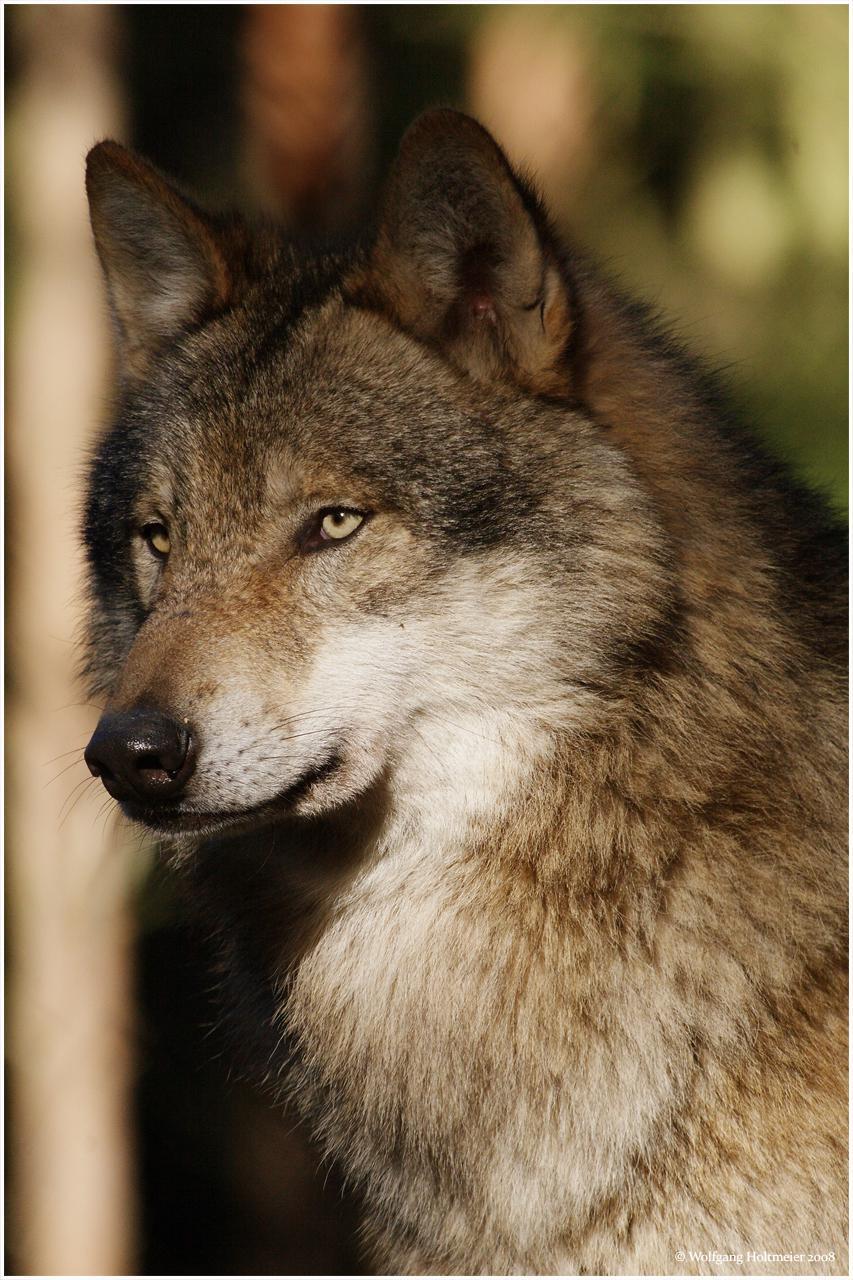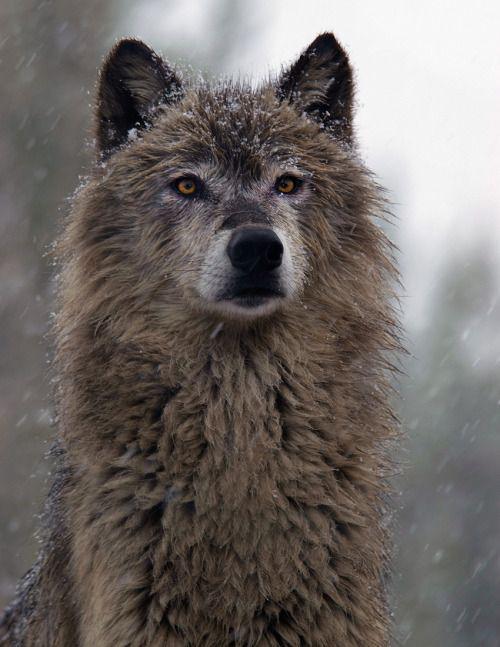The first image is the image on the left, the second image is the image on the right. Examine the images to the left and right. Is the description "Each image shows the face of one wolf, and one of the wolves depicted looks straight ahead, while the other is turned slightly to the left." accurate? Answer yes or no. Yes. 